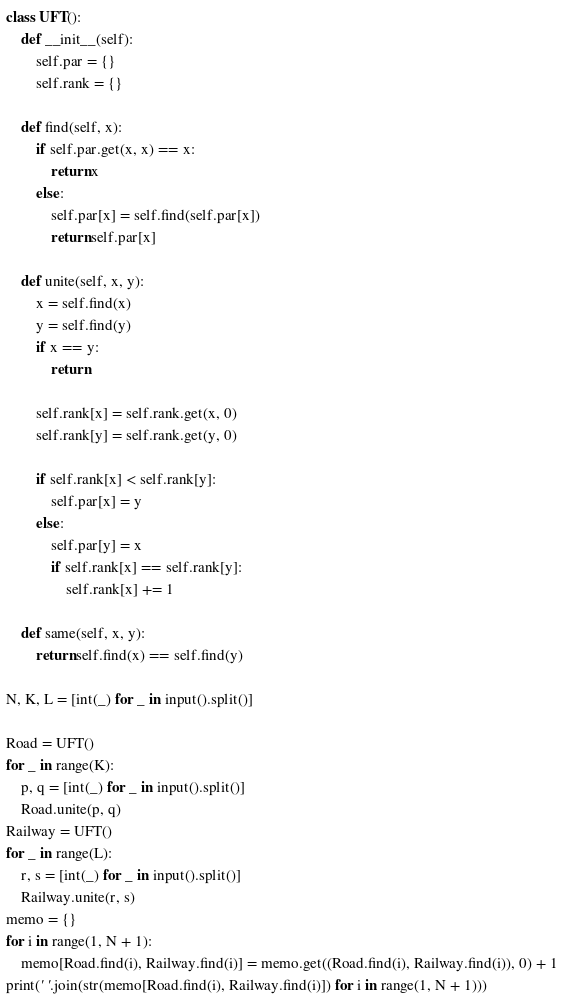<code> <loc_0><loc_0><loc_500><loc_500><_Python_>class UFT():
    def __init__(self):
        self.par = {}
        self.rank = {}

    def find(self, x):
        if self.par.get(x, x) == x:
            return x
        else:
            self.par[x] = self.find(self.par[x])
            return self.par[x]

    def unite(self, x, y):
        x = self.find(x)
        y = self.find(y)
        if x == y:
            return

        self.rank[x] = self.rank.get(x, 0)
        self.rank[y] = self.rank.get(y, 0)

        if self.rank[x] < self.rank[y]:
            self.par[x] = y
        else:
            self.par[y] = x
            if self.rank[x] == self.rank[y]:
                self.rank[x] += 1

    def same(self, x, y):
        return self.find(x) == self.find(y)

N, K, L = [int(_) for _ in input().split()]

Road = UFT()
for _ in range(K):
    p, q = [int(_) for _ in input().split()]
    Road.unite(p, q)
Railway = UFT()
for _ in range(L):
    r, s = [int(_) for _ in input().split()]
    Railway.unite(r, s)
memo = {}
for i in range(1, N + 1):
    memo[Road.find(i), Railway.find(i)] = memo.get((Road.find(i), Railway.find(i)), 0) + 1
print(' '.join(str(memo[Road.find(i), Railway.find(i)]) for i in range(1, N + 1)))
</code> 